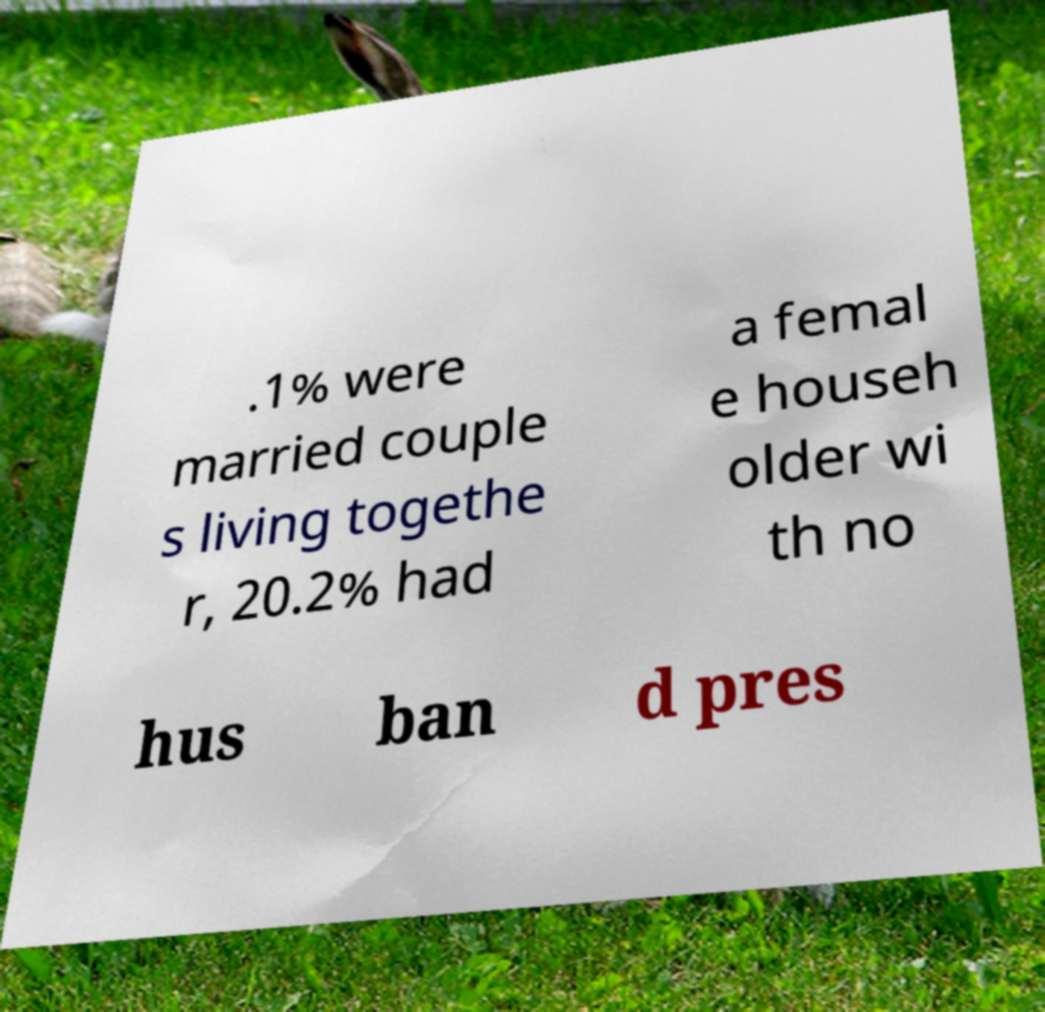Please identify and transcribe the text found in this image. .1% were married couple s living togethe r, 20.2% had a femal e househ older wi th no hus ban d pres 